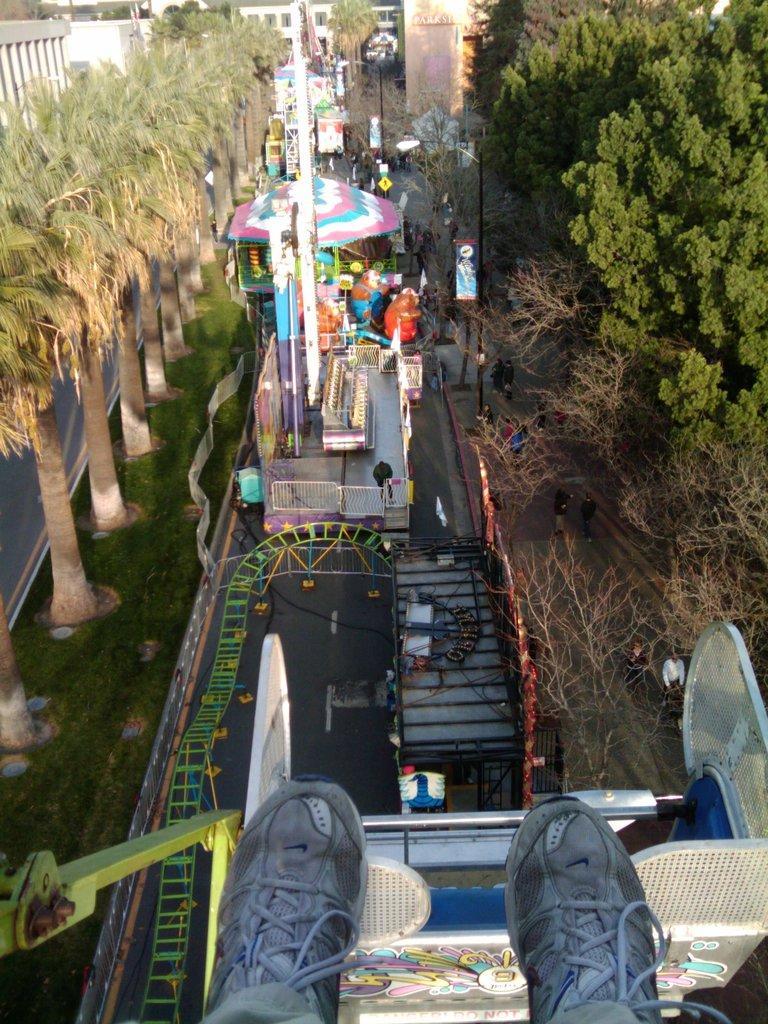Can you describe this image briefly? This is a top view of an amusement park. I can see a roller coaster. This image is taken by a person sitting in a roller coaster I can see his feet. I can see many other toys and game zones in this image. I can see trees on both sides of the image I can see buildings at the top of the image. 